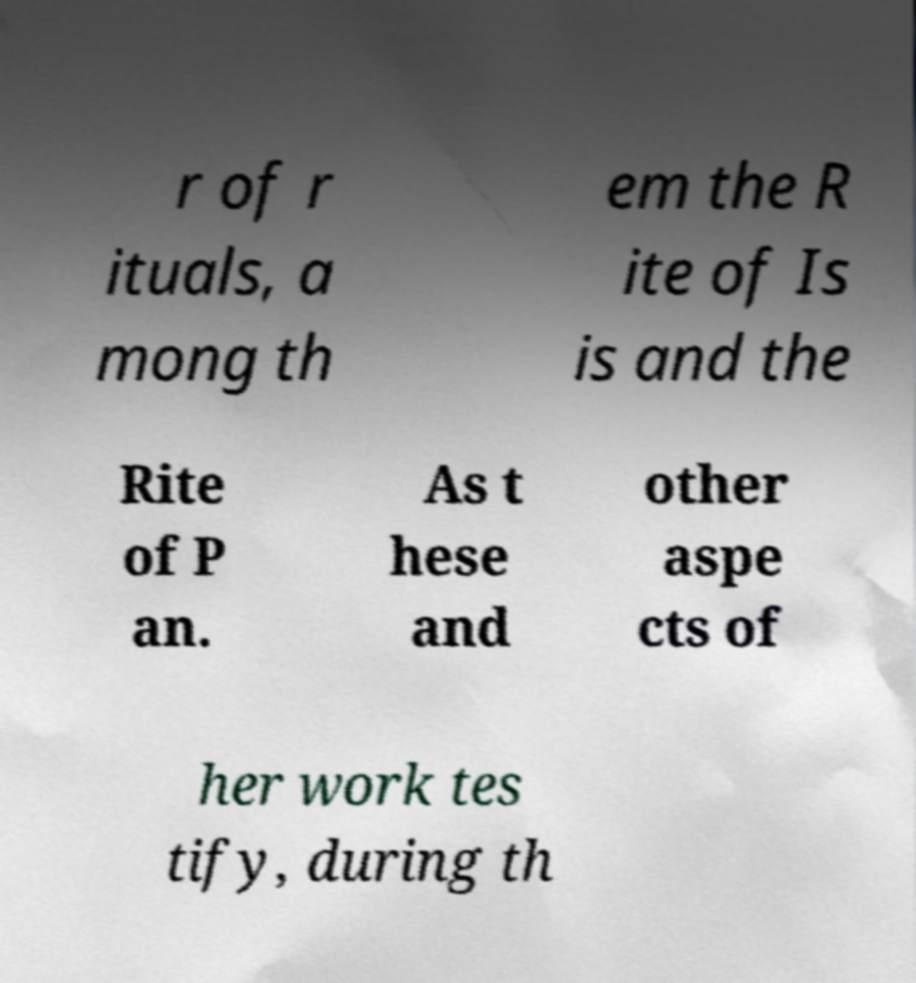For documentation purposes, I need the text within this image transcribed. Could you provide that? r of r ituals, a mong th em the R ite of Is is and the Rite of P an. As t hese and other aspe cts of her work tes tify, during th 